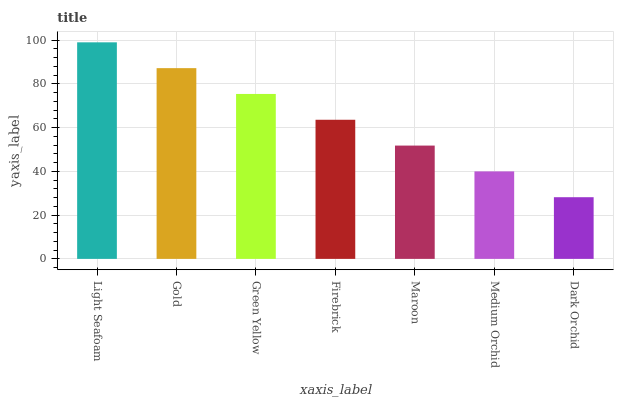Is Dark Orchid the minimum?
Answer yes or no. Yes. Is Light Seafoam the maximum?
Answer yes or no. Yes. Is Gold the minimum?
Answer yes or no. No. Is Gold the maximum?
Answer yes or no. No. Is Light Seafoam greater than Gold?
Answer yes or no. Yes. Is Gold less than Light Seafoam?
Answer yes or no. Yes. Is Gold greater than Light Seafoam?
Answer yes or no. No. Is Light Seafoam less than Gold?
Answer yes or no. No. Is Firebrick the high median?
Answer yes or no. Yes. Is Firebrick the low median?
Answer yes or no. Yes. Is Gold the high median?
Answer yes or no. No. Is Light Seafoam the low median?
Answer yes or no. No. 